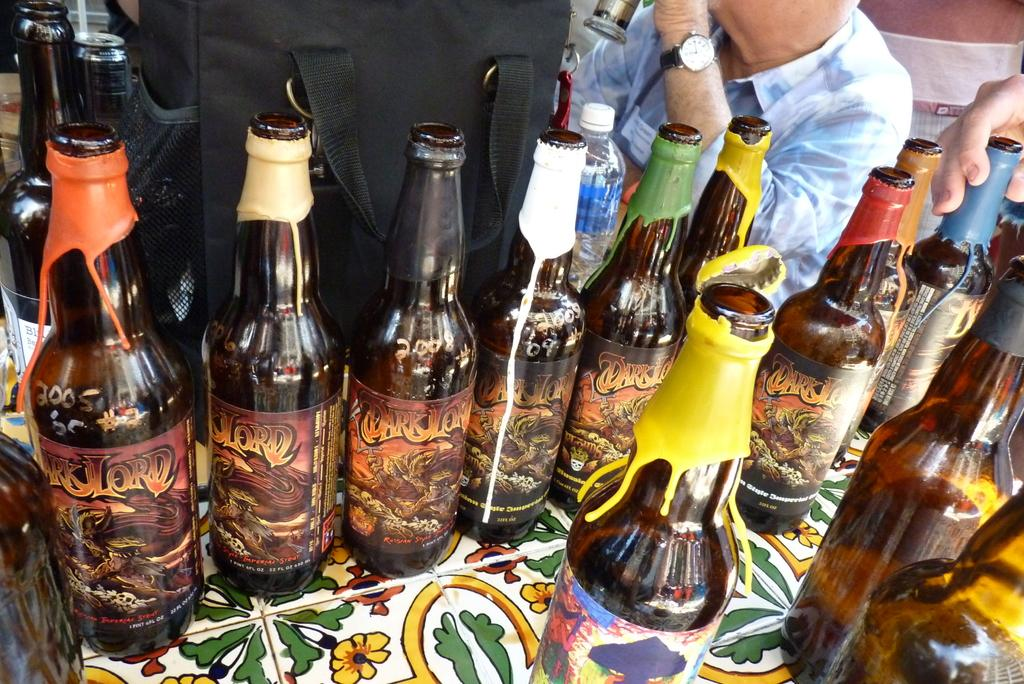Provide a one-sentence caption for the provided image. Bottles of Dark Lord beer with colorful wax seals. 